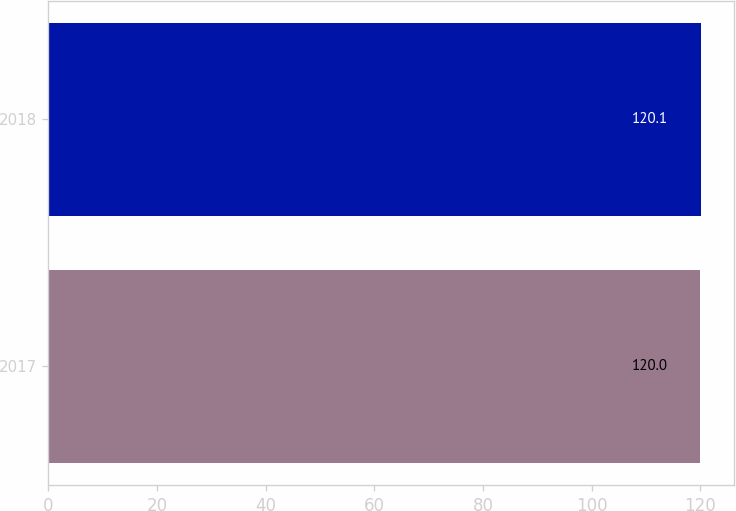Convert chart to OTSL. <chart><loc_0><loc_0><loc_500><loc_500><bar_chart><fcel>2017<fcel>2018<nl><fcel>120<fcel>120.1<nl></chart> 